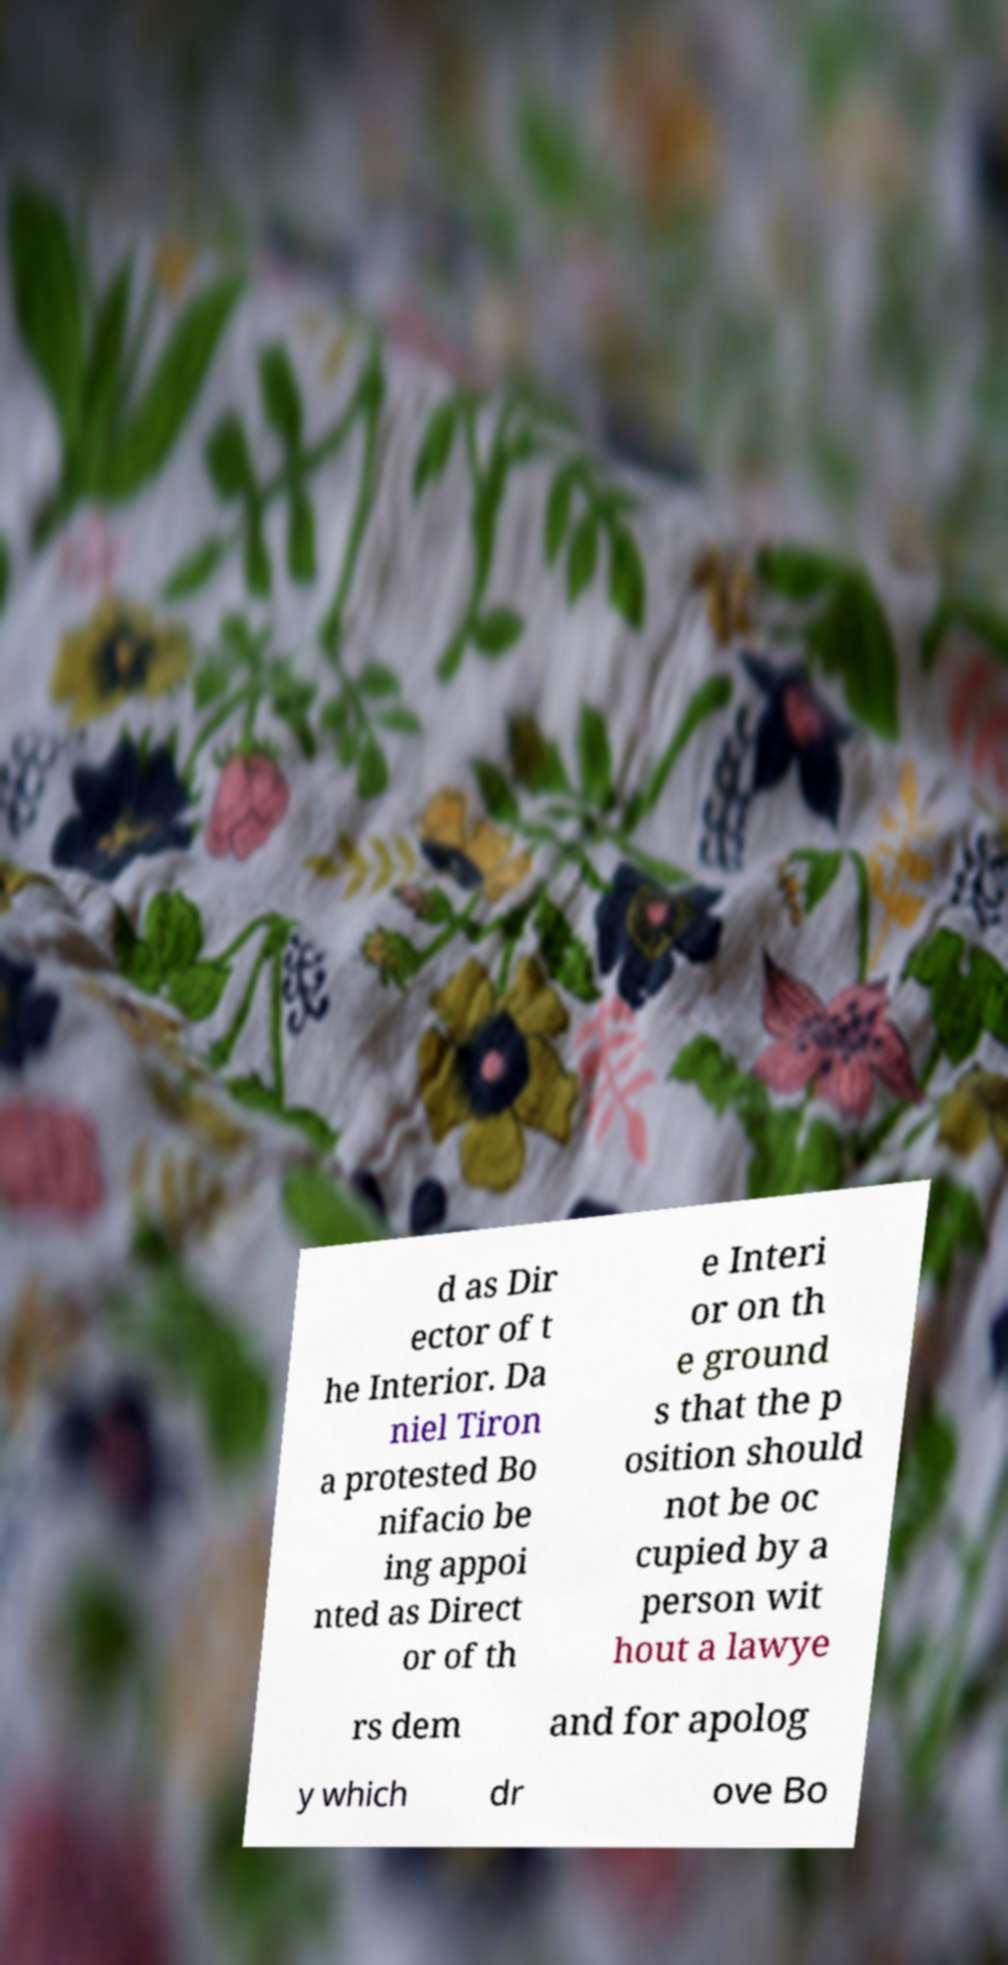Please identify and transcribe the text found in this image. d as Dir ector of t he Interior. Da niel Tiron a protested Bo nifacio be ing appoi nted as Direct or of th e Interi or on th e ground s that the p osition should not be oc cupied by a person wit hout a lawye rs dem and for apolog y which dr ove Bo 